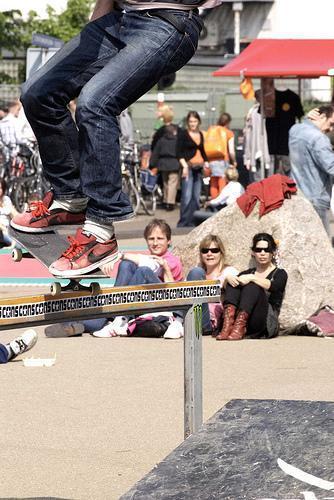How many people are leaning on the rock?
Give a very brief answer. 3. How many women in sunglasses?
Give a very brief answer. 2. How many pink shirts?
Give a very brief answer. 1. 